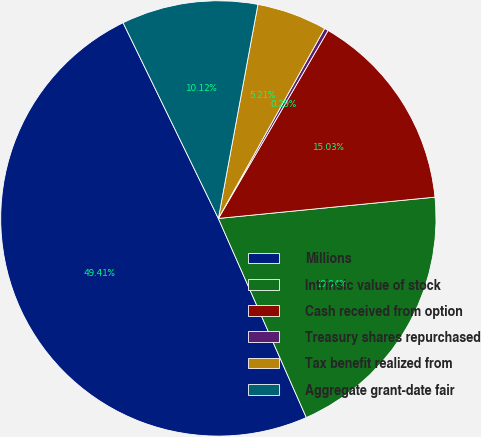Convert chart. <chart><loc_0><loc_0><loc_500><loc_500><pie_chart><fcel>Millions<fcel>Intrinsic value of stock<fcel>Cash received from option<fcel>Treasury shares repurchased<fcel>Tax benefit realized from<fcel>Aggregate grant-date fair<nl><fcel>49.41%<fcel>19.94%<fcel>15.03%<fcel>0.29%<fcel>5.21%<fcel>10.12%<nl></chart> 